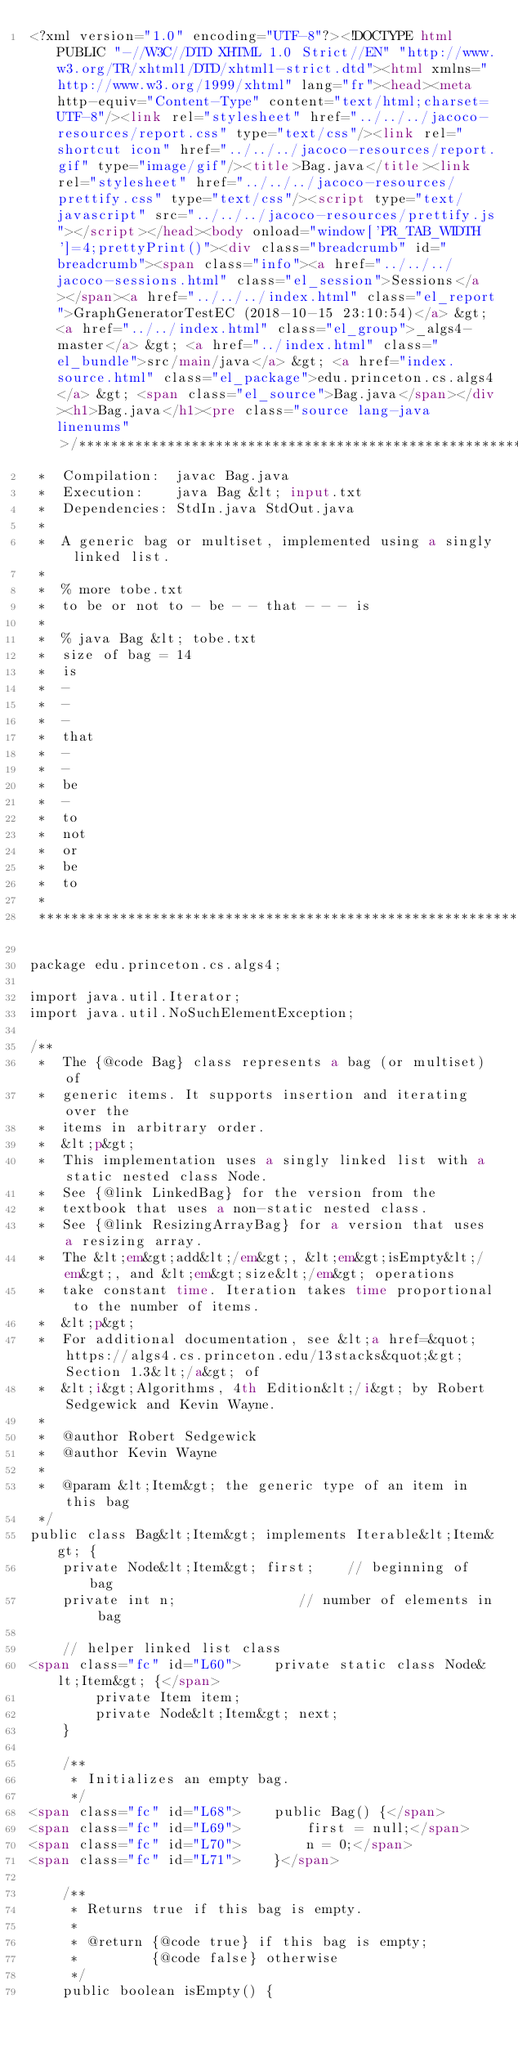Convert code to text. <code><loc_0><loc_0><loc_500><loc_500><_HTML_><?xml version="1.0" encoding="UTF-8"?><!DOCTYPE html PUBLIC "-//W3C//DTD XHTML 1.0 Strict//EN" "http://www.w3.org/TR/xhtml1/DTD/xhtml1-strict.dtd"><html xmlns="http://www.w3.org/1999/xhtml" lang="fr"><head><meta http-equiv="Content-Type" content="text/html;charset=UTF-8"/><link rel="stylesheet" href="../../../jacoco-resources/report.css" type="text/css"/><link rel="shortcut icon" href="../../../jacoco-resources/report.gif" type="image/gif"/><title>Bag.java</title><link rel="stylesheet" href="../../../jacoco-resources/prettify.css" type="text/css"/><script type="text/javascript" src="../../../jacoco-resources/prettify.js"></script></head><body onload="window['PR_TAB_WIDTH']=4;prettyPrint()"><div class="breadcrumb" id="breadcrumb"><span class="info"><a href="../../../jacoco-sessions.html" class="el_session">Sessions</a></span><a href="../../../index.html" class="el_report">GraphGeneratorTestEC (2018-10-15 23:10:54)</a> &gt; <a href="../../index.html" class="el_group">_algs4-master</a> &gt; <a href="../index.html" class="el_bundle">src/main/java</a> &gt; <a href="index.source.html" class="el_package">edu.princeton.cs.algs4</a> &gt; <span class="el_source">Bag.java</span></div><h1>Bag.java</h1><pre class="source lang-java linenums">/******************************************************************************
 *  Compilation:  javac Bag.java
 *  Execution:    java Bag &lt; input.txt
 *  Dependencies: StdIn.java StdOut.java
 *
 *  A generic bag or multiset, implemented using a singly linked list.
 *
 *  % more tobe.txt 
 *  to be or not to - be - - that - - - is
 *
 *  % java Bag &lt; tobe.txt
 *  size of bag = 14
 *  is
 *  -
 *  -
 *  -
 *  that
 *  -
 *  -
 *  be
 *  -
 *  to
 *  not
 *  or
 *  be
 *  to
 *
 ******************************************************************************/

package edu.princeton.cs.algs4;

import java.util.Iterator;
import java.util.NoSuchElementException;

/**
 *  The {@code Bag} class represents a bag (or multiset) of 
 *  generic items. It supports insertion and iterating over the 
 *  items in arbitrary order.
 *  &lt;p&gt;
 *  This implementation uses a singly linked list with a static nested class Node.
 *  See {@link LinkedBag} for the version from the
 *  textbook that uses a non-static nested class.
 *  See {@link ResizingArrayBag} for a version that uses a resizing array.
 *  The &lt;em&gt;add&lt;/em&gt;, &lt;em&gt;isEmpty&lt;/em&gt;, and &lt;em&gt;size&lt;/em&gt; operations
 *  take constant time. Iteration takes time proportional to the number of items.
 *  &lt;p&gt;
 *  For additional documentation, see &lt;a href=&quot;https://algs4.cs.princeton.edu/13stacks&quot;&gt;Section 1.3&lt;/a&gt; of
 *  &lt;i&gt;Algorithms, 4th Edition&lt;/i&gt; by Robert Sedgewick and Kevin Wayne.
 *
 *  @author Robert Sedgewick
 *  @author Kevin Wayne
 *
 *  @param &lt;Item&gt; the generic type of an item in this bag
 */
public class Bag&lt;Item&gt; implements Iterable&lt;Item&gt; {
    private Node&lt;Item&gt; first;    // beginning of bag
    private int n;               // number of elements in bag

    // helper linked list class
<span class="fc" id="L60">    private static class Node&lt;Item&gt; {</span>
        private Item item;
        private Node&lt;Item&gt; next;
    }

    /**
     * Initializes an empty bag.
     */
<span class="fc" id="L68">    public Bag() {</span>
<span class="fc" id="L69">        first = null;</span>
<span class="fc" id="L70">        n = 0;</span>
<span class="fc" id="L71">    }</span>

    /**
     * Returns true if this bag is empty.
     *
     * @return {@code true} if this bag is empty;
     *         {@code false} otherwise
     */
    public boolean isEmpty() {</code> 